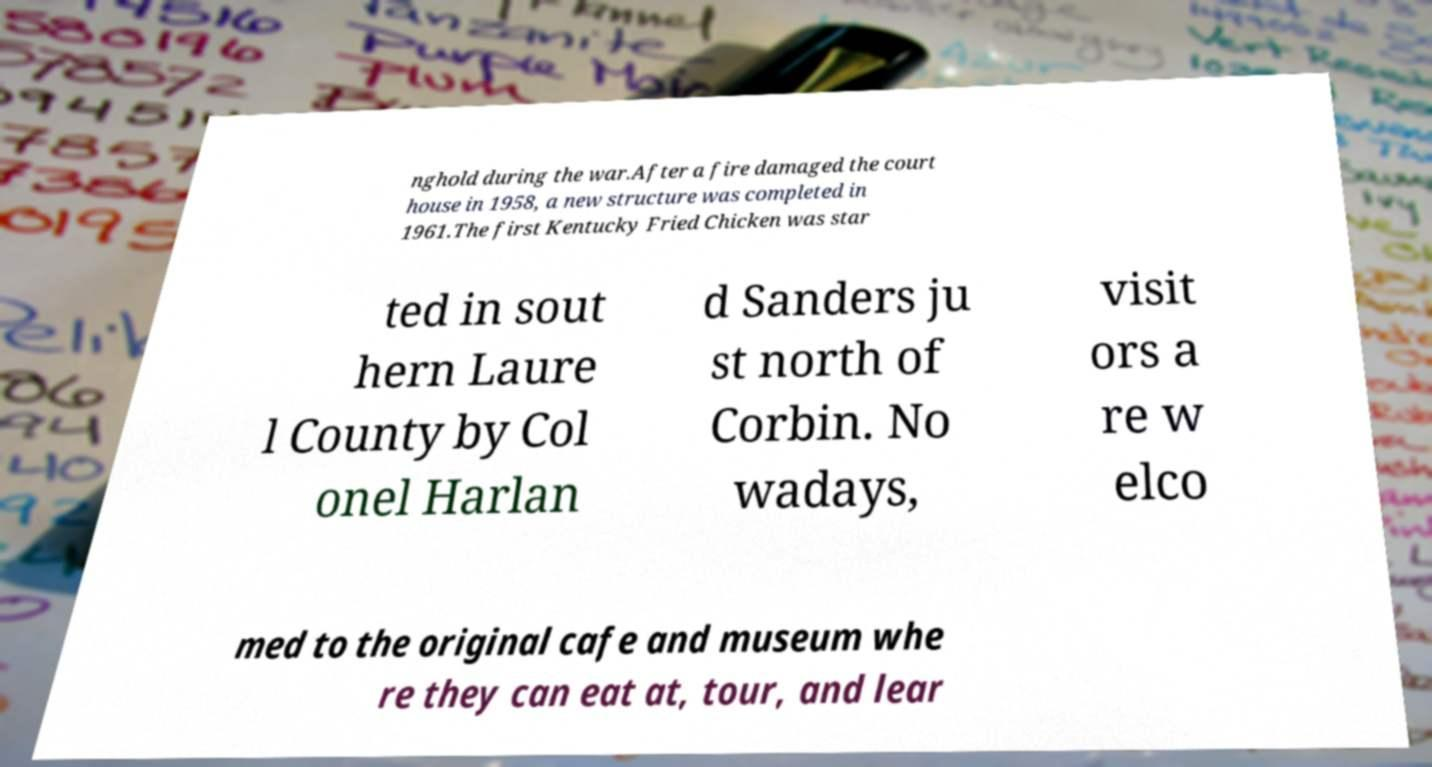For documentation purposes, I need the text within this image transcribed. Could you provide that? nghold during the war.After a fire damaged the court house in 1958, a new structure was completed in 1961.The first Kentucky Fried Chicken was star ted in sout hern Laure l County by Col onel Harlan d Sanders ju st north of Corbin. No wadays, visit ors a re w elco med to the original cafe and museum whe re they can eat at, tour, and lear 